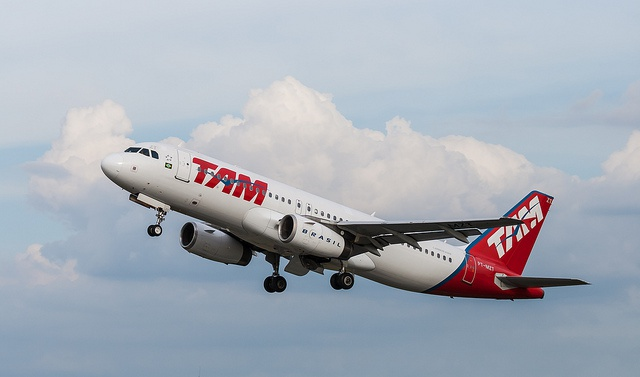Describe the objects in this image and their specific colors. I can see a airplane in lightgray, black, darkgray, and gray tones in this image. 